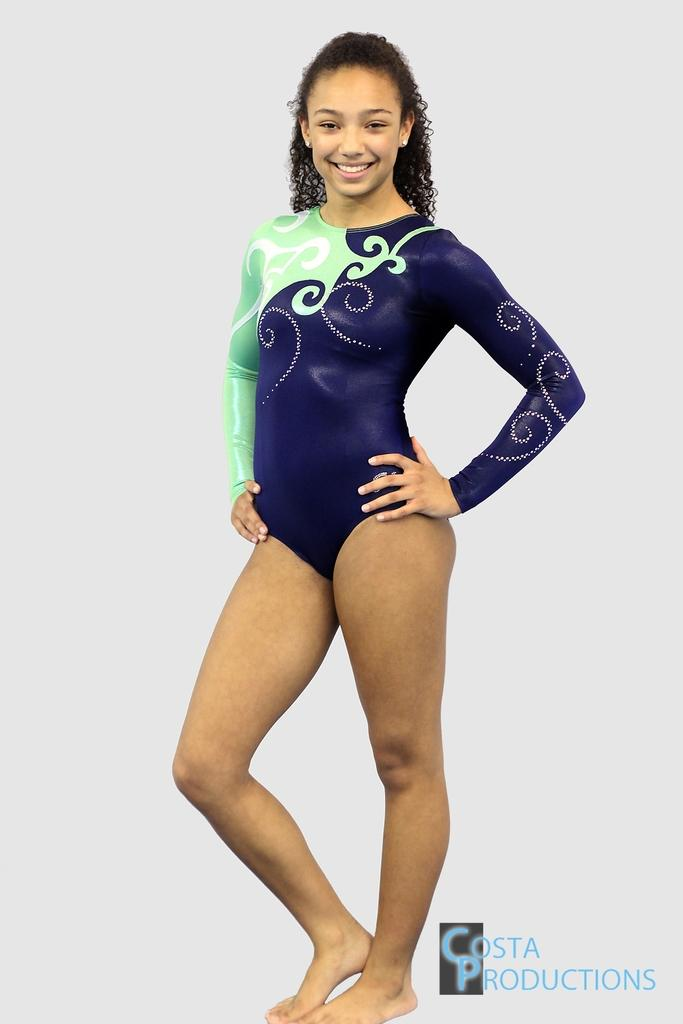Who is the main subject in the image? There is a woman in the image. Where is the woman positioned in the image? The woman is standing in the middle of the image. What is the woman's facial expression? The woman is smiling. Is there any text or marking in the image? Yes, there is a watermark in the bottom right corner of the image. What type of shoe is the woman wearing in the image? There is no shoe visible in the image, as the woman is not wearing any footwear. What type of root can be seen growing near the woman in the image? There are no roots present in the image; it is a woman standing in the middle of the frame. 